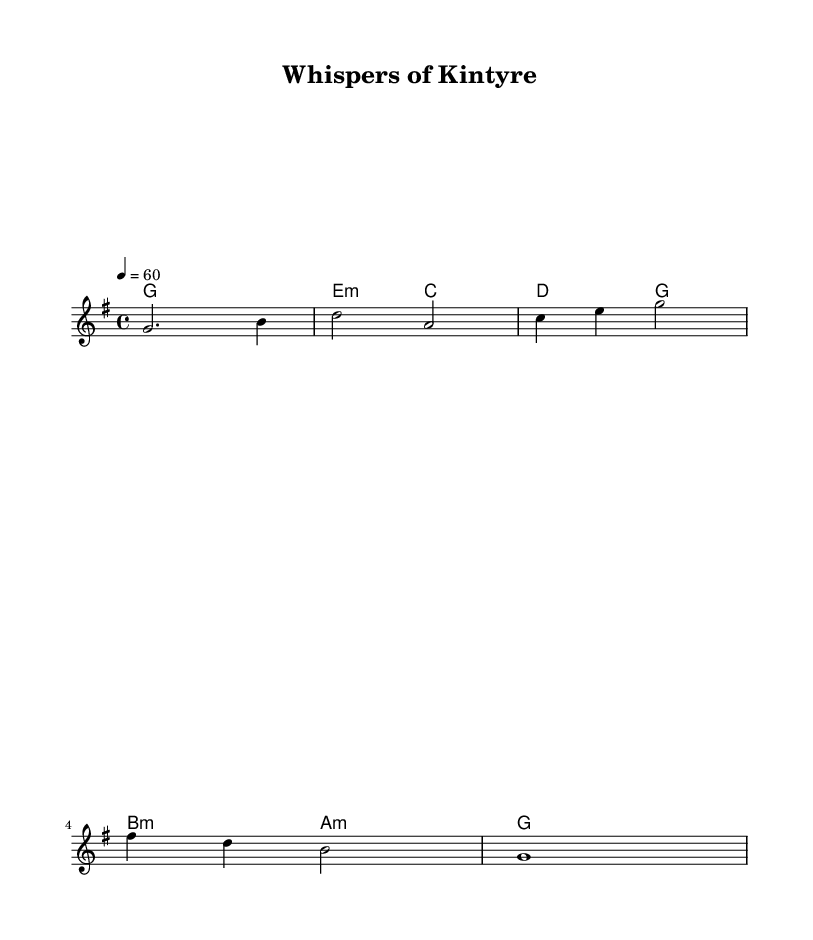What is the key signature of this music? The key signature indicates the presence of one sharp, which signifies that the music is in G major.
Answer: G major What is the time signature of this piece? The time signature is represented near the beginning of the score as 4/4, indicating that there are four beats in each measure.
Answer: 4/4 What is the tempo marking of "Whispers of Kintyre"? The tempo marking is indicated by "4 = 60," which means that there are 60 beats per minute at a quarter note.
Answer: 60 How many measures are there in the melody? The melody consists of five measures, which can be counted based on the vertical lines separating the sections of music.
Answer: 5 What is the first note of the melody? The first note in the melody is G, which is indicated by the notehead placed on the second line of the treble staff.
Answer: G What is the final chord in the harmonic progression? The final chord is G major, which is indicated by the note G in the last measure of the harmony section.
Answer: G Is this piece more likely to evoke feelings of tranquility or excitement? Given the ambient nature of the music, characterized by sustained notes and gentle progressions, it is more likely to evoke feelings of tranquility.
Answer: Tranquility 